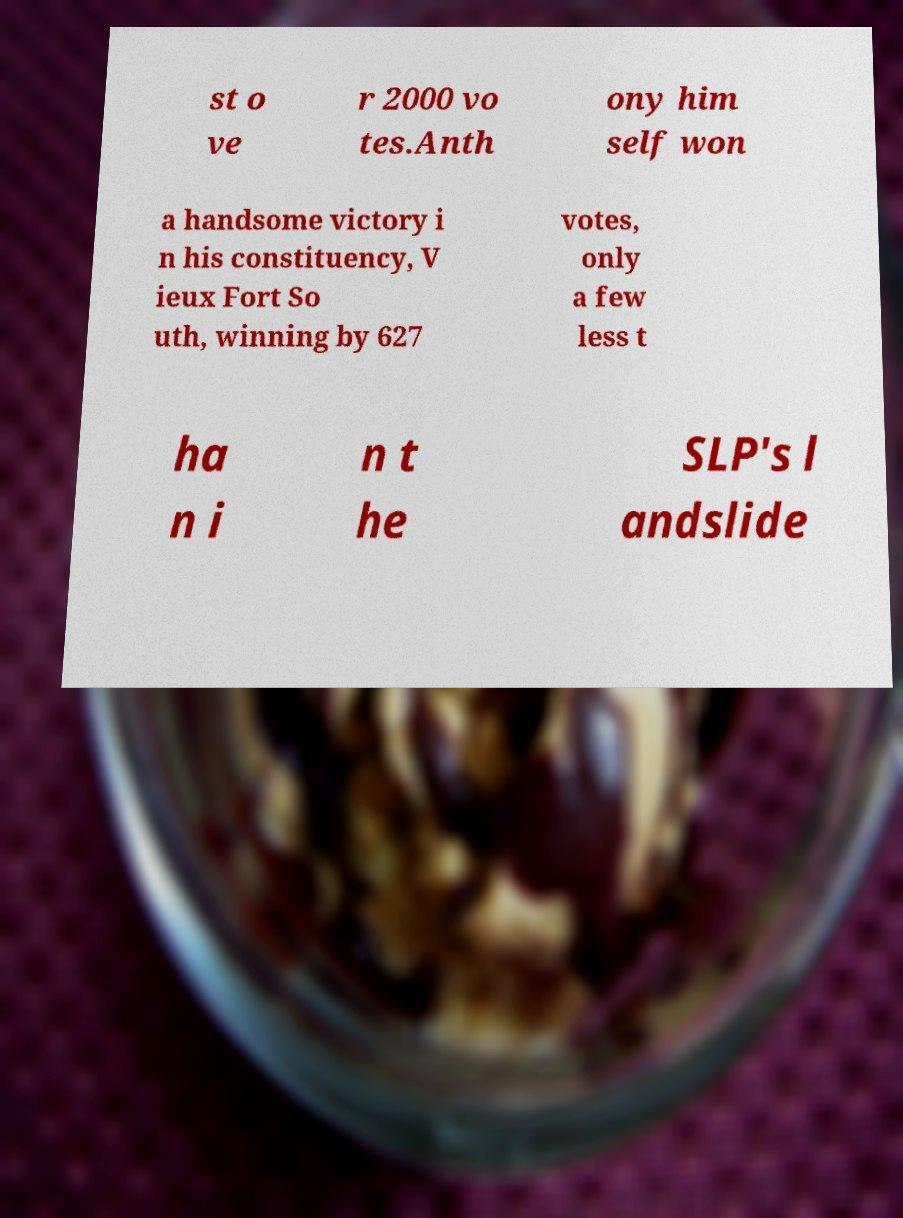Please read and relay the text visible in this image. What does it say? st o ve r 2000 vo tes.Anth ony him self won a handsome victory i n his constituency, V ieux Fort So uth, winning by 627 votes, only a few less t ha n i n t he SLP's l andslide 